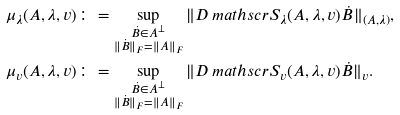<formula> <loc_0><loc_0><loc_500><loc_500>\mu _ { \lambda } ( A , \lambda , v ) & \colon = \sup _ { \substack { \dot { B } \in A ^ { \perp } \\ \| \dot { B } \| _ { F } = \| A \| _ { F } } } \| D \ m a t h s c r { S } _ { \lambda } ( A , \lambda , v ) \dot { B } \| _ { ( A , \lambda ) } , \\ \mu _ { v } ( A , \lambda , v ) & \colon = \sup _ { \substack { \dot { B } \in A ^ { \perp } \\ \| \dot { B } \| _ { F } = \| A \| _ { F } } } \| D \ m a t h s c r { S } _ { v } ( A , \lambda , v ) \dot { B } \| _ { v } .</formula> 